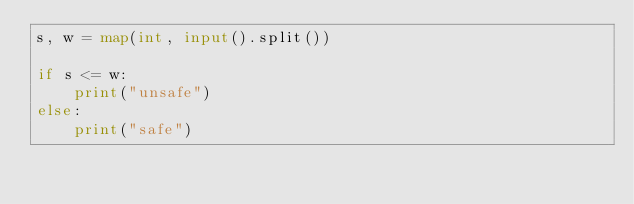Convert code to text. <code><loc_0><loc_0><loc_500><loc_500><_Python_>s, w = map(int, input().split())

if s <= w:
    print("unsafe")
else:
    print("safe")</code> 